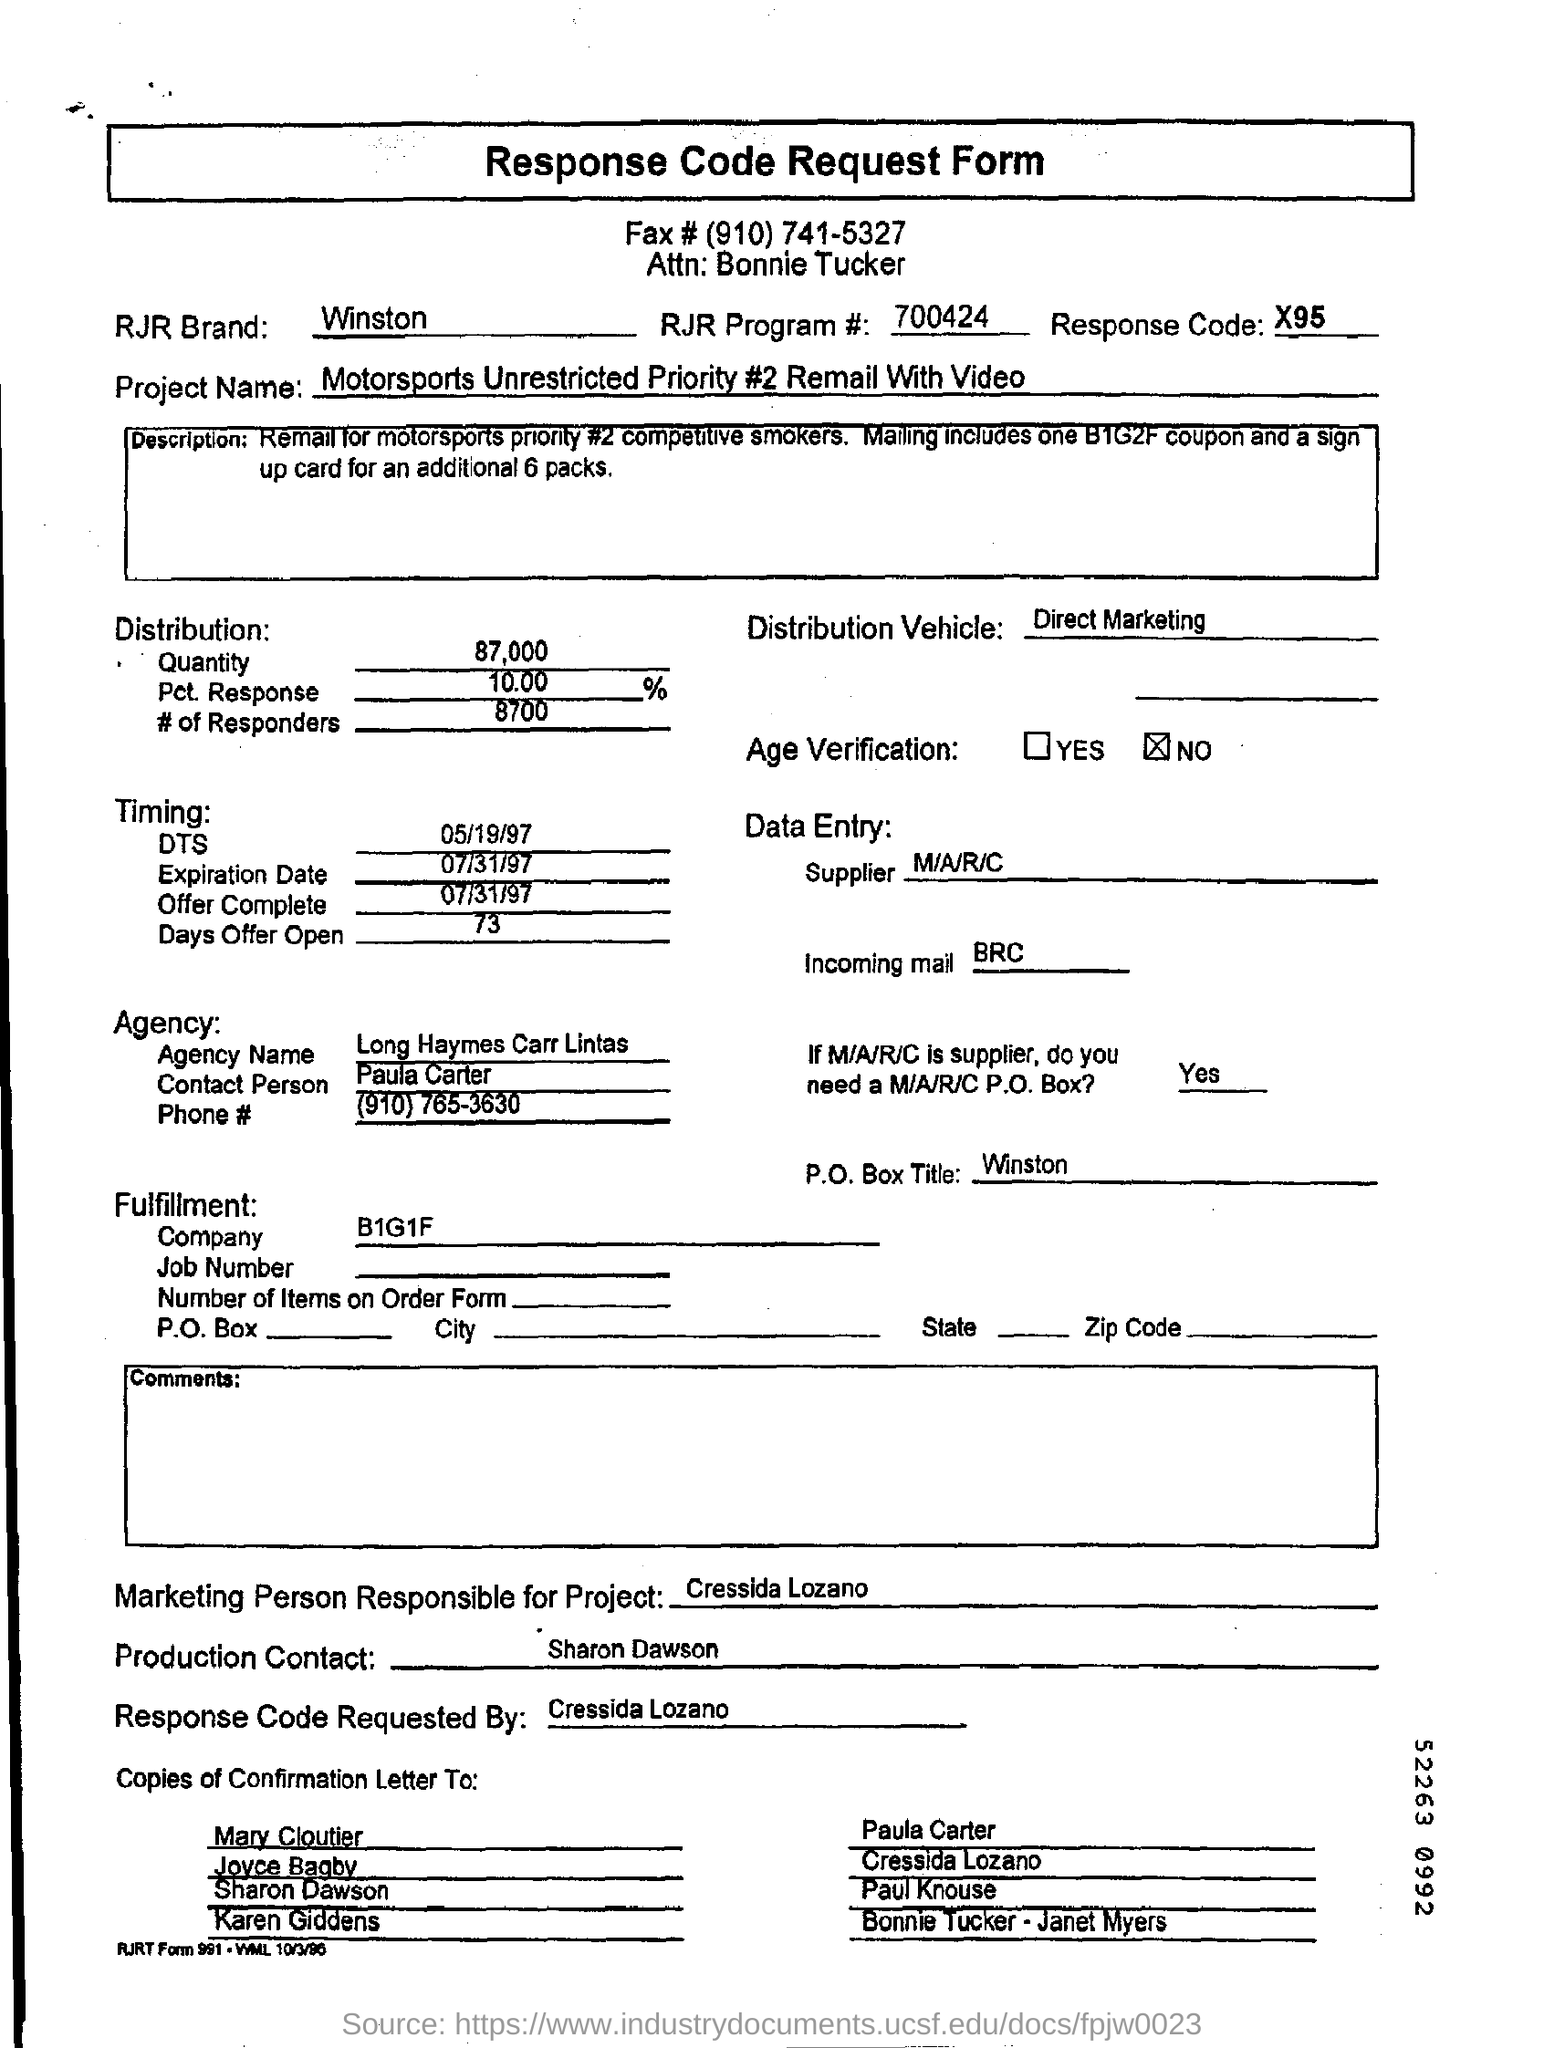Outline some significant characteristics in this image. The RJR brand name is Winston. The RJR Program Number is 700424.... The distribution vehicle field contains the information "Direct Marketing. The expiration date is July 31, 1997. The fax number is (910) 741-5327. 